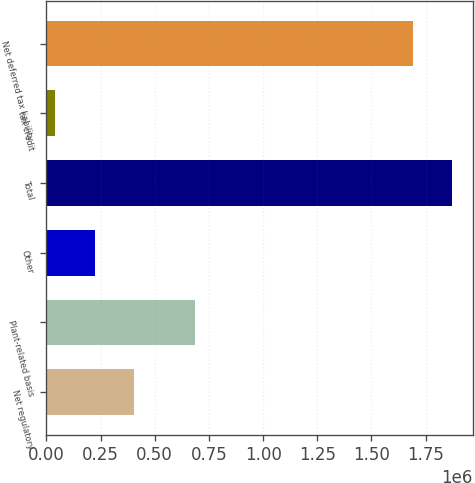<chart> <loc_0><loc_0><loc_500><loc_500><bar_chart><fcel>Net regulatory<fcel>Plant-related basis<fcel>Other<fcel>Total<fcel>tax credit<fcel>Net deferred tax liability<nl><fcel>404967<fcel>683590<fcel>222981<fcel>1.87316e+06<fcel>40995<fcel>1.69117e+06<nl></chart> 